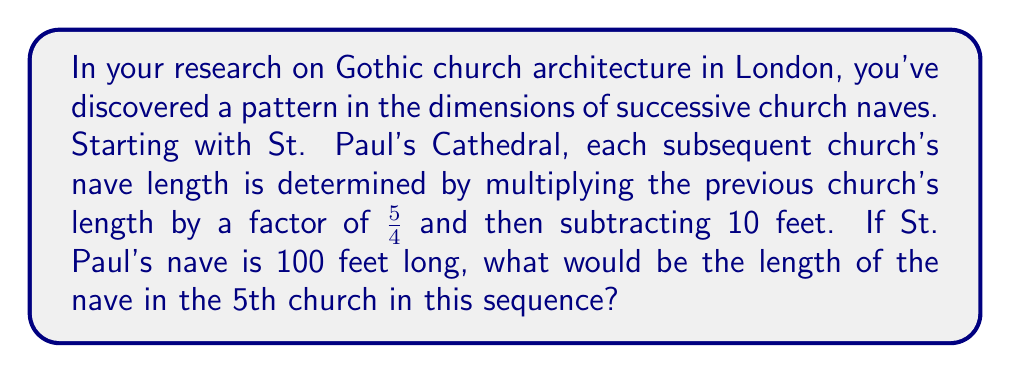Teach me how to tackle this problem. Let's approach this step-by-step:

1) We start with St. Paul's Cathedral nave length: 100 feet

2) For each subsequent church, we multiply by $\frac{5}{4}$ and subtract 10 feet.

3) Let's calculate the lengths for each church:

   Church 1 (St. Paul's): 100 feet

   Church 2: $100 \cdot \frac{5}{4} - 10 = 125 - 10 = 115$ feet

   Church 3: $115 \cdot \frac{5}{4} - 10 = 143.75 - 10 = 133.75$ feet

   Church 4: $133.75 \cdot \frac{5}{4} - 10 = 167.1875 - 10 = 157.1875$ feet

   Church 5: $157.1875 \cdot \frac{5}{4} - 10 = 196.484375 - 10 = 186.484375$ feet

4) We can express this as a general formula:

   $$a_n = a_{n-1} \cdot \frac{5}{4} - 10$$

   where $a_n$ is the length of the nth church's nave.

5) The 5th church in the sequence corresponds to $n=5$ in our calculations.

Therefore, the length of the nave in the 5th church would be 186.484375 feet.
Answer: 186.484375 feet 